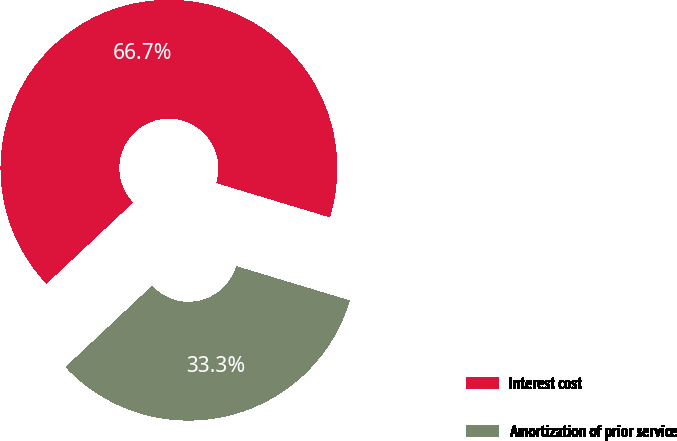Convert chart. <chart><loc_0><loc_0><loc_500><loc_500><pie_chart><fcel>Interest cost<fcel>Amortization of prior service<nl><fcel>66.67%<fcel>33.33%<nl></chart> 